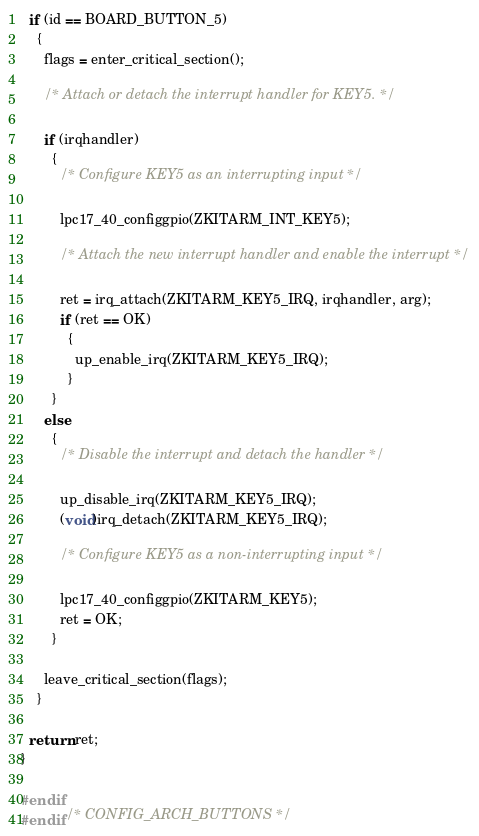<code> <loc_0><loc_0><loc_500><loc_500><_C_>  if (id == BOARD_BUTTON_5)
    {
      flags = enter_critical_section();

      /* Attach or detach the interrupt handler for KEY5. */

      if (irqhandler)
        {
          /* Configure KEY5 as an interrupting input */

          lpc17_40_configgpio(ZKITARM_INT_KEY5);

          /* Attach the new interrupt handler and enable the interrupt */

          ret = irq_attach(ZKITARM_KEY5_IRQ, irqhandler, arg);
          if (ret == OK)
            {
              up_enable_irq(ZKITARM_KEY5_IRQ);
            }
        }
      else
        {
          /* Disable the interrupt and detach the handler */

          up_disable_irq(ZKITARM_KEY5_IRQ);
          (void)irq_detach(ZKITARM_KEY5_IRQ);

          /* Configure KEY5 as a non-interrupting input */

          lpc17_40_configgpio(ZKITARM_KEY5);
          ret = OK;
        }

      leave_critical_section(flags);
    }

  return ret;
}

#endif
#endif /* CONFIG_ARCH_BUTTONS */
</code> 